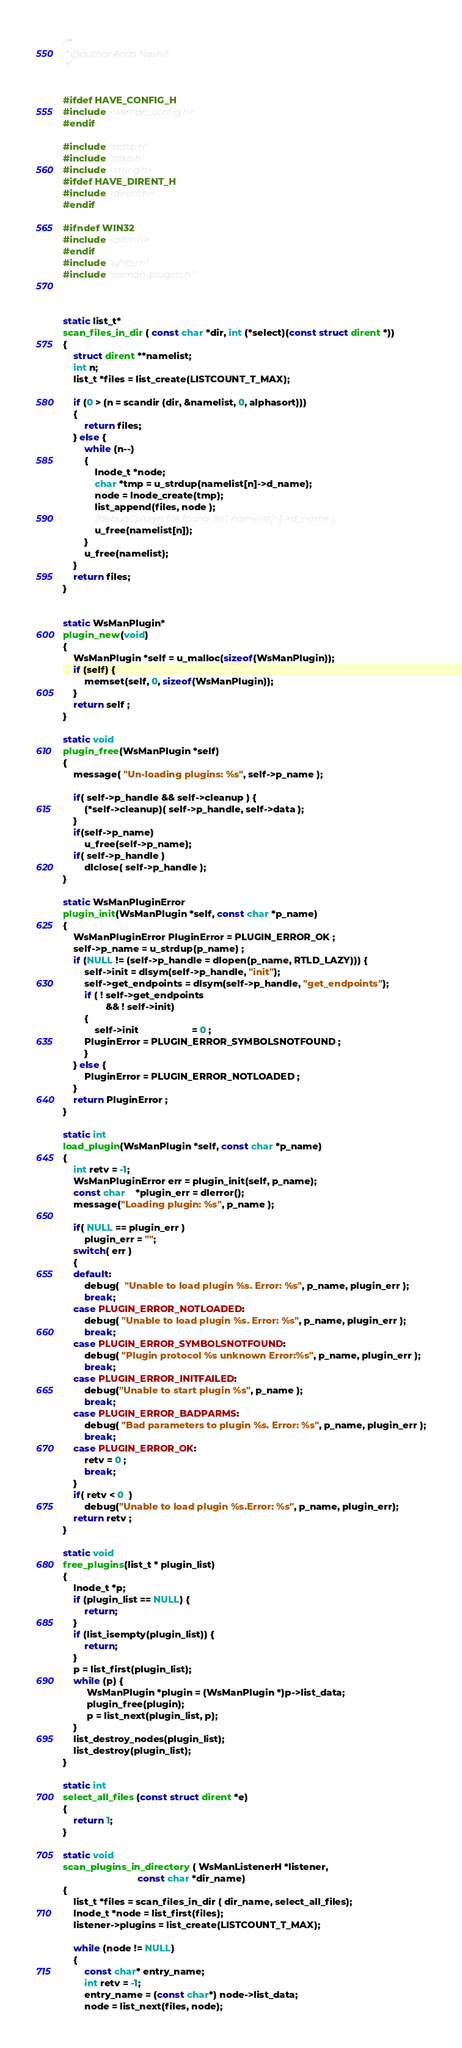Convert code to text. <code><loc_0><loc_0><loc_500><loc_500><_C_>/**
 * @author Anas Nashif
 */


#ifdef HAVE_CONFIG_H
#include <wsman_config.h>
#endif

#include "stdlib.h"
#include "stdio.h"
#include <string.h>
#ifdef HAVE_DIRENT_H
#include <dirent.h>
#endif

#ifndef WIN32
#include <dlfcn.h>
#endif
#include "u/libu.h"
#include "wsman-plugins.h"



static list_t*
scan_files_in_dir ( const char *dir, int (*select)(const struct dirent *))
{
    struct dirent **namelist;
    int n;
    list_t *files = list_create(LISTCOUNT_T_MAX);

    if (0 > (n = scandir (dir, &namelist, 0, alphasort)))
    {
        return files;
    } else {
        while (n--)
        {
			lnode_t *node;
            char *tmp = u_strdup(namelist[n]->d_name);
            node = lnode_create(tmp);
            list_append(files, node );
            //debug("plugin file found: %s", namelist[n]->d_name );
            u_free(namelist[n]);
        }
        u_free(namelist);
    }
    return files;
}


static WsManPlugin*
plugin_new(void)
{
    WsManPlugin *self = u_malloc(sizeof(WsManPlugin));
    if (self) {
        memset(self, 0, sizeof(WsManPlugin));
    }
    return self ;
}

static void
plugin_free(WsManPlugin *self)
{
    message( "Un-loading plugins: %s", self->p_name );

    if( self->p_handle && self->cleanup ) {
        (*self->cleanup)( self->p_handle, self->data );
    }
    if(self->p_name)
        u_free(self->p_name);
    if( self->p_handle )
        dlclose( self->p_handle );
}

static WsManPluginError
plugin_init(WsManPlugin *self, const char *p_name)
{
    WsManPluginError PluginError = PLUGIN_ERROR_OK ;
    self->p_name = u_strdup(p_name) ;
    if (NULL != (self->p_handle = dlopen(p_name, RTLD_LAZY))) {
        self->init = dlsym(self->p_handle, "init");
        self->get_endpoints = dlsym(self->p_handle, "get_endpoints");
        if ( ! self->get_endpoints
                && ! self->init)
        {
            self->init			        = 0 ;
	    PluginError = PLUGIN_ERROR_SYMBOLSNOTFOUND ;
        }
    } else {
        PluginError = PLUGIN_ERROR_NOTLOADED ;
    }
    return PluginError ;
}

static int
load_plugin(WsManPlugin *self, const char *p_name)
{
    int retv = -1;
    WsManPluginError err = plugin_init(self, p_name);
    const char	*plugin_err = dlerror();
    message("Loading plugin: %s", p_name );

	if( NULL == plugin_err )
        plugin_err = "";
    switch( err )
    {
    default:
        debug(  "Unable to load plugin %s. Error: %s", p_name, plugin_err );
        break;
    case PLUGIN_ERROR_NOTLOADED:
        debug( "Unable to load plugin %s. Error: %s", p_name, plugin_err );
        break;
    case PLUGIN_ERROR_SYMBOLSNOTFOUND:
        debug( "Plugin protocol %s unknown Error:%s", p_name, plugin_err );
        break;
    case PLUGIN_ERROR_INITFAILED:
        debug("Unable to start plugin %s", p_name );
        break;
    case PLUGIN_ERROR_BADPARMS:
        debug( "Bad parameters to plugin %s. Error: %s", p_name, plugin_err );
        break;
    case PLUGIN_ERROR_OK:
        retv = 0 ;
        break;
    }
    if( retv < 0  )
        debug("Unable to load plugin %s.Error: %s", p_name, plugin_err);
    return retv ;
}

static void
free_plugins(list_t * plugin_list)
{
	lnode_t *p;
    if (plugin_list == NULL) {
        return;
    }
    if (list_isempty(plugin_list)) {
        return;
    }
    p = list_first(plugin_list);
    while (p) {
         WsManPlugin *plugin = (WsManPlugin *)p->list_data;
         plugin_free(plugin);
         p = list_next(plugin_list, p);
    }
    list_destroy_nodes(plugin_list);
    list_destroy(plugin_list);
}

static int
select_all_files (const struct dirent *e)
{
    return 1;
}

static void
scan_plugins_in_directory ( WsManListenerH *listener,
                            const char *dir_name)
{
	list_t *files = scan_files_in_dir ( dir_name, select_all_files);
	lnode_t *node = list_first(files);
    listener->plugins = list_create(LISTCOUNT_T_MAX);

    while (node != NULL)
    {
        const char* entry_name;
        int retv = -1;
        entry_name = (const char*) node->list_data;
        node = list_next(files, node);
</code> 